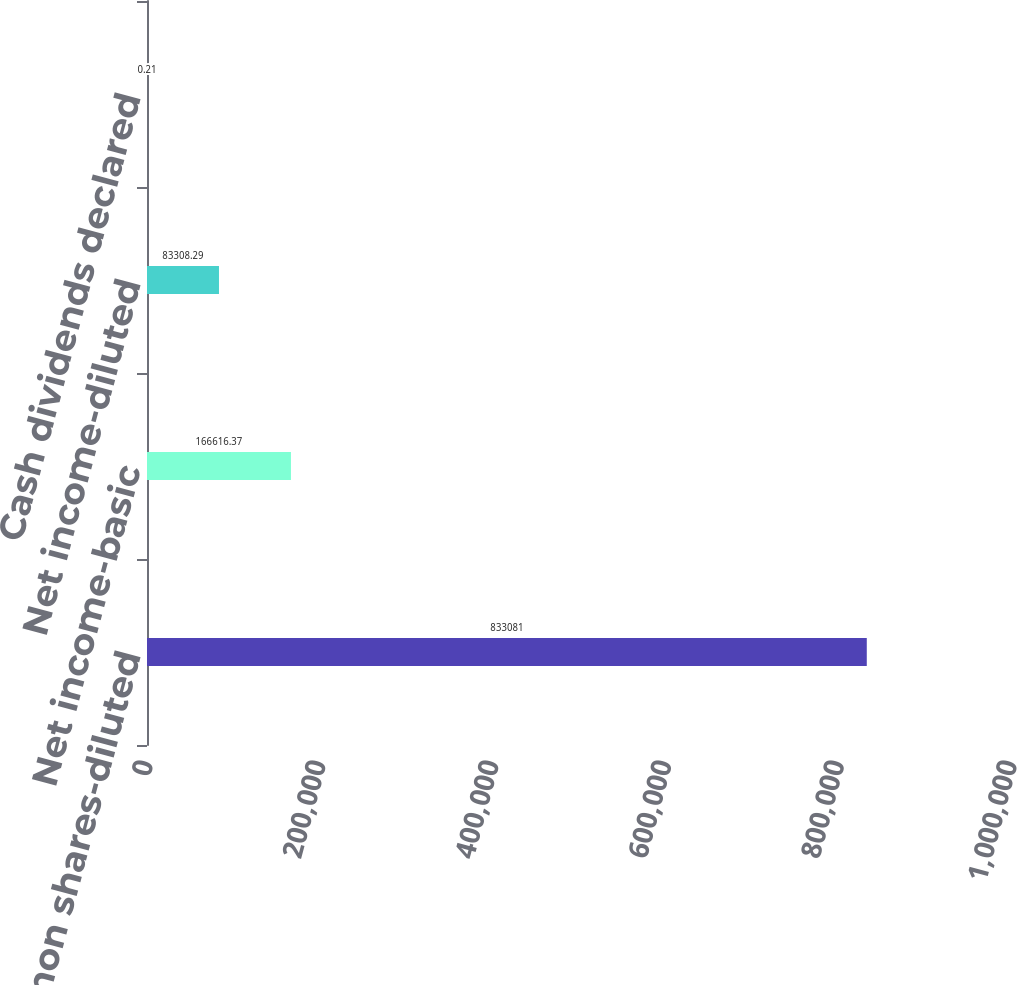Convert chart to OTSL. <chart><loc_0><loc_0><loc_500><loc_500><bar_chart><fcel>Average common shares-diluted<fcel>Net income-basic<fcel>Net income-diluted<fcel>Cash dividends declared<nl><fcel>833081<fcel>166616<fcel>83308.3<fcel>0.21<nl></chart> 